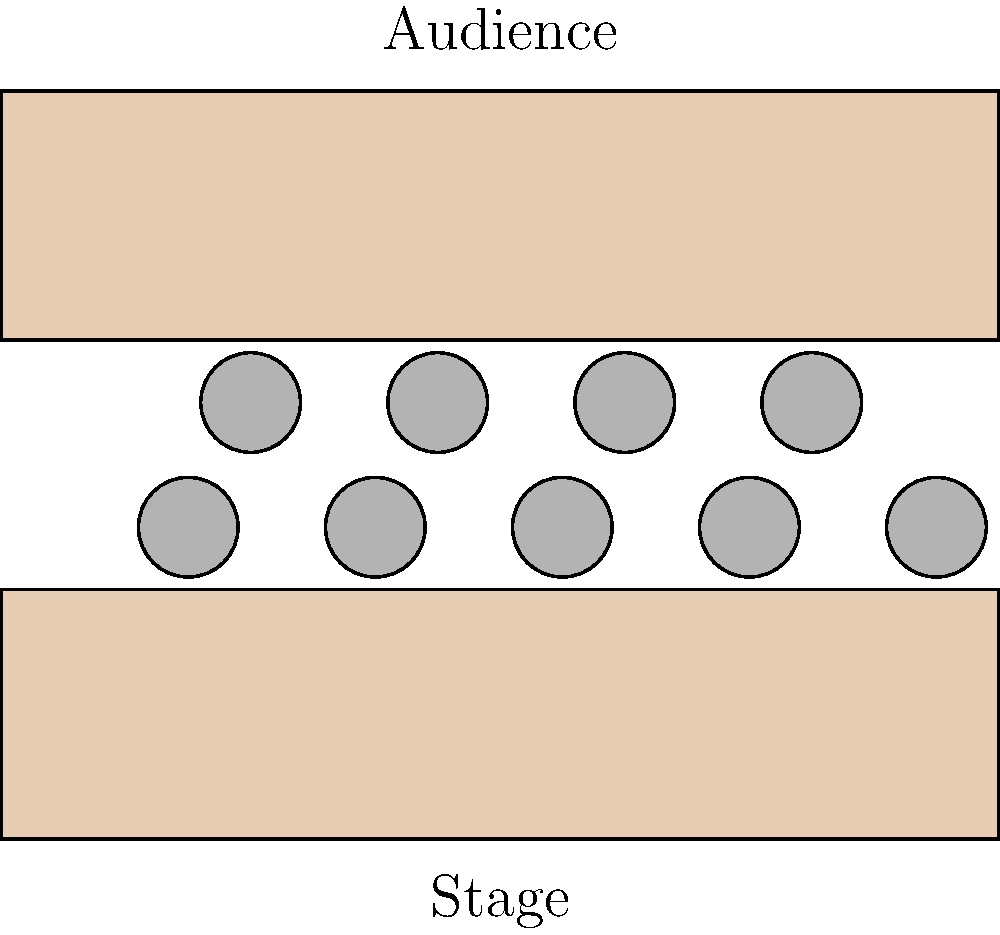As an event coordinator for a film festival panel discussion, you need to arrange seating for international filmmakers. The diagram shows a setup with two rectangular tables and multiple chairs. How many additional chairs can be added to the front row while maintaining equal spacing between chairs and ensuring that the outermost chairs are aligned with the edges of the tables? To determine how many additional chairs can be added to the front row, let's follow these steps:

1. Observe that the current setup has 5 chairs in the front row.
2. The tables appear to be of equal length, spanning the width of the diagram.
3. The chairs are evenly spaced, with the outermost chairs aligned with the edges of the tables.
4. To maintain equal spacing and alignment with table edges, we need to calculate the maximum number of evenly spaced chairs that can fit along the table length.

5. Let's assume the table length is 8 units (based on the diagram scale).
6. With 5 chairs, there are 4 spaces between chairs, plus 2 half-spaces at the ends.
7. Total spaces = 5 (number of current chairs)
8. Space between chairs = 8 (table length) ÷ 5 (total spaces) = 1.6 units

9. To find the maximum number of chairs:
   - Maximum chairs = (Table length ÷ Space between chairs) + 1
   - Maximum chairs = (8 ÷ 1.6) + 1 = 6

10. Therefore, the maximum number of chairs that can fit in the front row is 6.
11. Additional chairs that can be added = Maximum chairs - Current chairs
12. Additional chairs = 6 - 5 = 1
Answer: 1 chair 